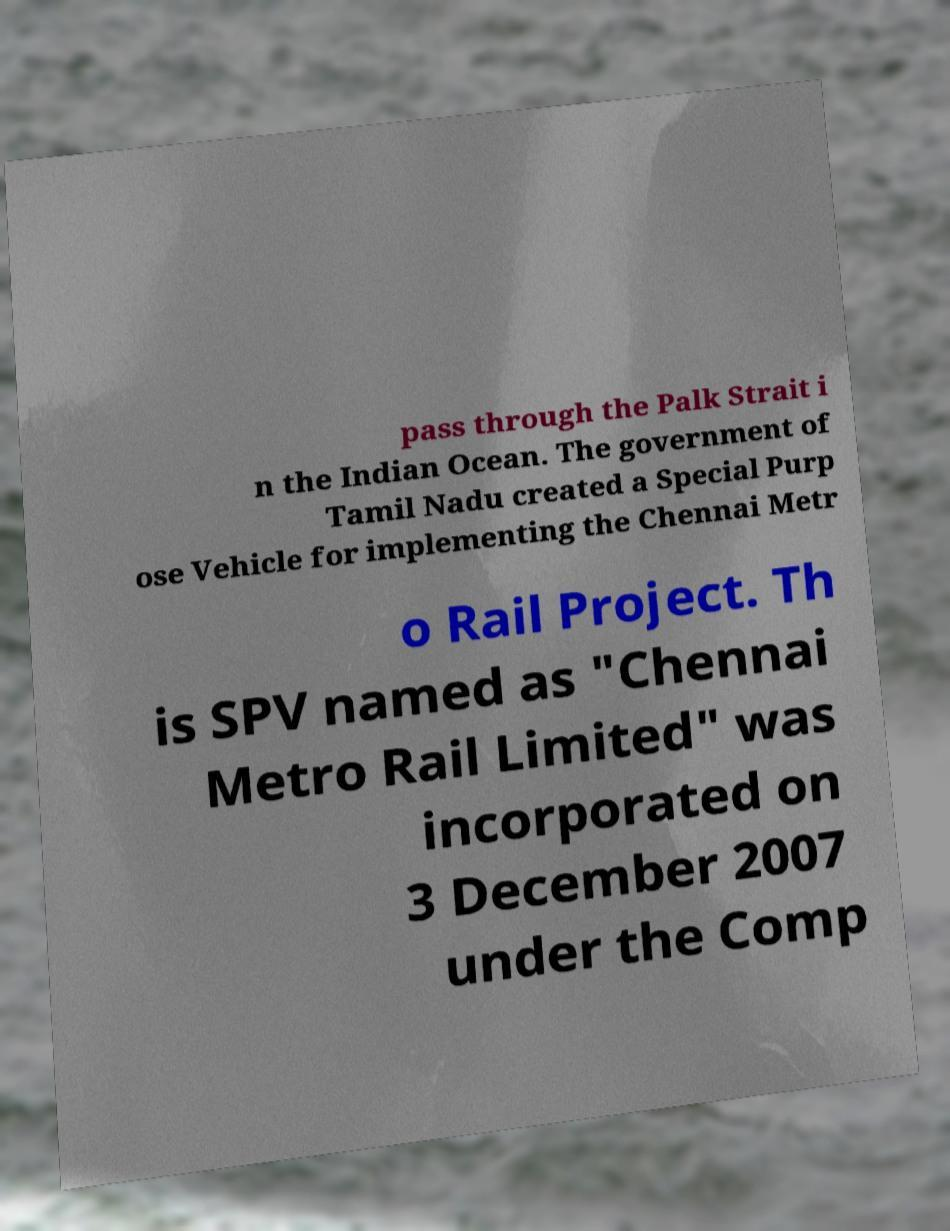For documentation purposes, I need the text within this image transcribed. Could you provide that? pass through the Palk Strait i n the Indian Ocean. The government of Tamil Nadu created a Special Purp ose Vehicle for implementing the Chennai Metr o Rail Project. Th is SPV named as "Chennai Metro Rail Limited" was incorporated on 3 December 2007 under the Comp 